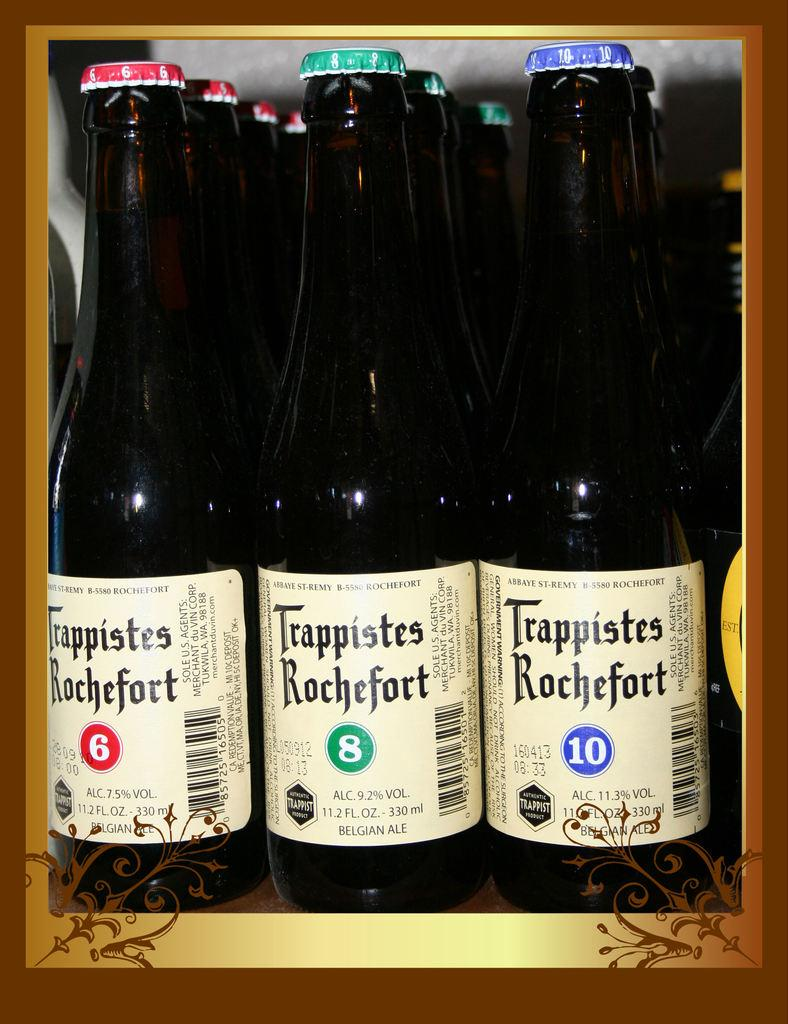<image>
Render a clear and concise summary of the photo. Three rows of Trappistes Rochefort beer placed by each other with numbers 6,8, and 10 on different ones. 